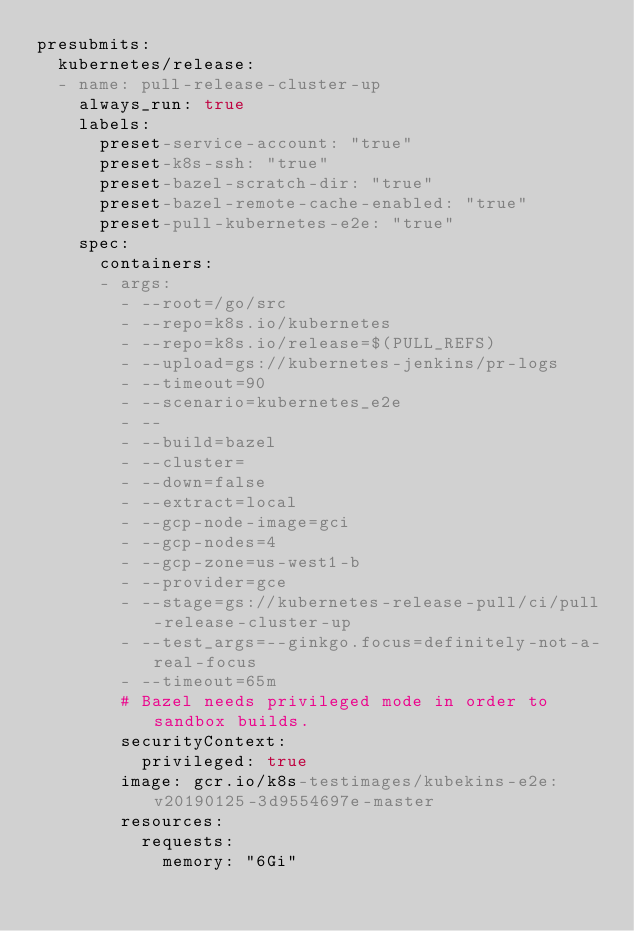Convert code to text. <code><loc_0><loc_0><loc_500><loc_500><_YAML_>presubmits:
  kubernetes/release:
  - name: pull-release-cluster-up
    always_run: true
    labels:
      preset-service-account: "true"
      preset-k8s-ssh: "true"
      preset-bazel-scratch-dir: "true"
      preset-bazel-remote-cache-enabled: "true"
      preset-pull-kubernetes-e2e: "true"
    spec:
      containers:
      - args:
        - --root=/go/src
        - --repo=k8s.io/kubernetes
        - --repo=k8s.io/release=$(PULL_REFS)
        - --upload=gs://kubernetes-jenkins/pr-logs
        - --timeout=90
        - --scenario=kubernetes_e2e
        - --
        - --build=bazel
        - --cluster=
        - --down=false
        - --extract=local
        - --gcp-node-image=gci
        - --gcp-nodes=4
        - --gcp-zone=us-west1-b
        - --provider=gce
        - --stage=gs://kubernetes-release-pull/ci/pull-release-cluster-up
        - --test_args=--ginkgo.focus=definitely-not-a-real-focus
        - --timeout=65m
        # Bazel needs privileged mode in order to sandbox builds.
        securityContext:
          privileged: true
        image: gcr.io/k8s-testimages/kubekins-e2e:v20190125-3d9554697e-master
        resources:
          requests:
            memory: "6Gi"
</code> 